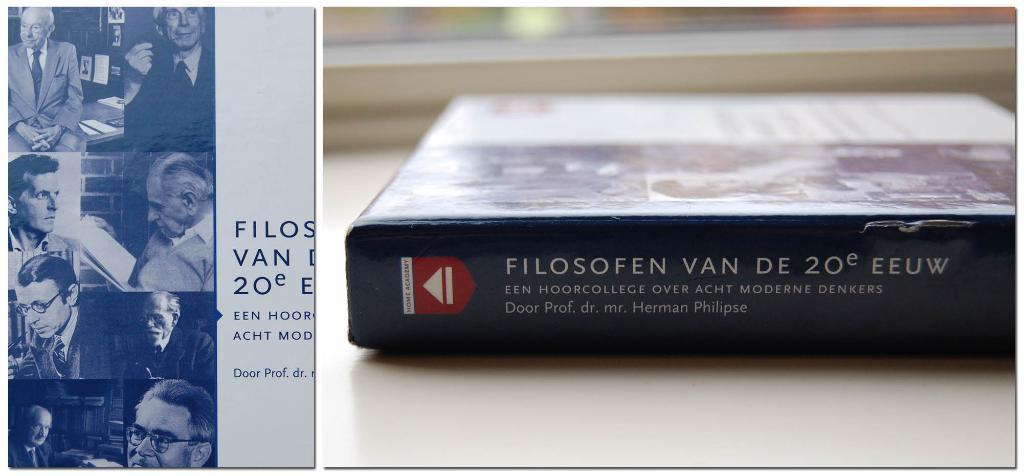<image>
Present a compact description of the photo's key features. The spine of a book that says Filosofen Van De 20 EEUW 